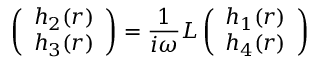<formula> <loc_0><loc_0><loc_500><loc_500>\left ( \begin{array} { c } { { h _ { 2 } ( r ) } } \\ { { h _ { 3 } ( r ) } } \end{array} \right ) = { \frac { 1 } { i \omega } } L \left ( \begin{array} { c } { { h _ { 1 } ( r ) } } \\ { { h _ { 4 } ( r ) } } \end{array} \right )</formula> 